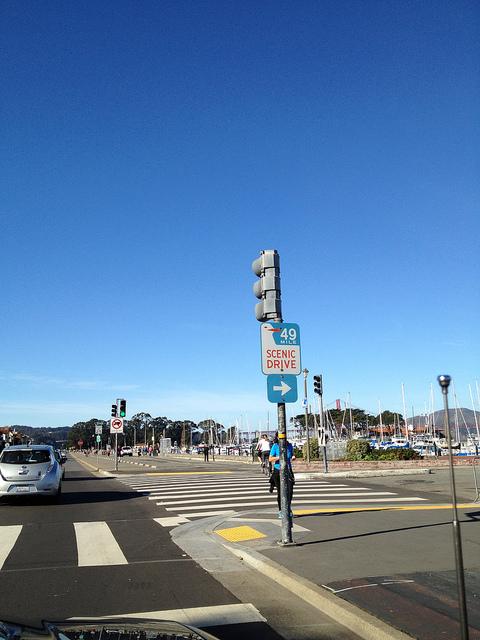Which way is the arrow pointing?
Keep it brief. Right. What color is traffic light in the back?
Keep it brief. Green. How many ways do the arrows point?
Be succinct. 1. Are the people in this photo?
Quick response, please. Yes. What number is visible on the sign?
Keep it brief. 49. 